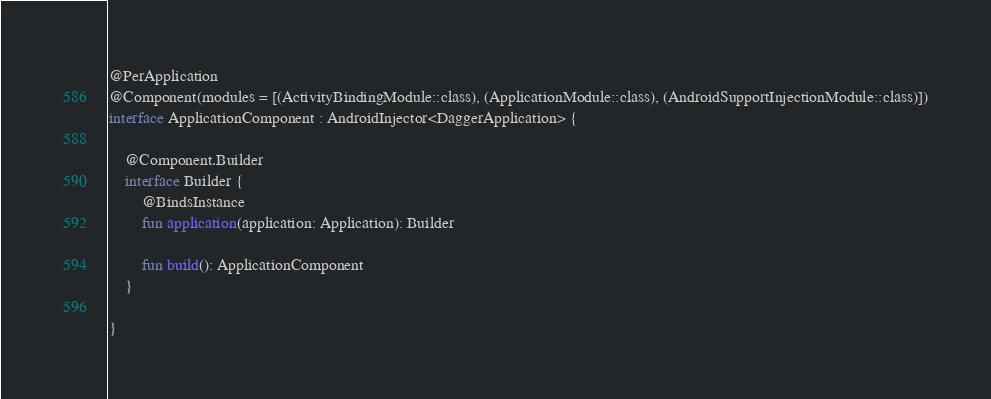<code> <loc_0><loc_0><loc_500><loc_500><_Kotlin_>@PerApplication
@Component(modules = [(ActivityBindingModule::class), (ApplicationModule::class), (AndroidSupportInjectionModule::class)])
interface ApplicationComponent : AndroidInjector<DaggerApplication> {

    @Component.Builder
    interface Builder {
        @BindsInstance
        fun application(application: Application): Builder

        fun build(): ApplicationComponent
    }

}
</code> 